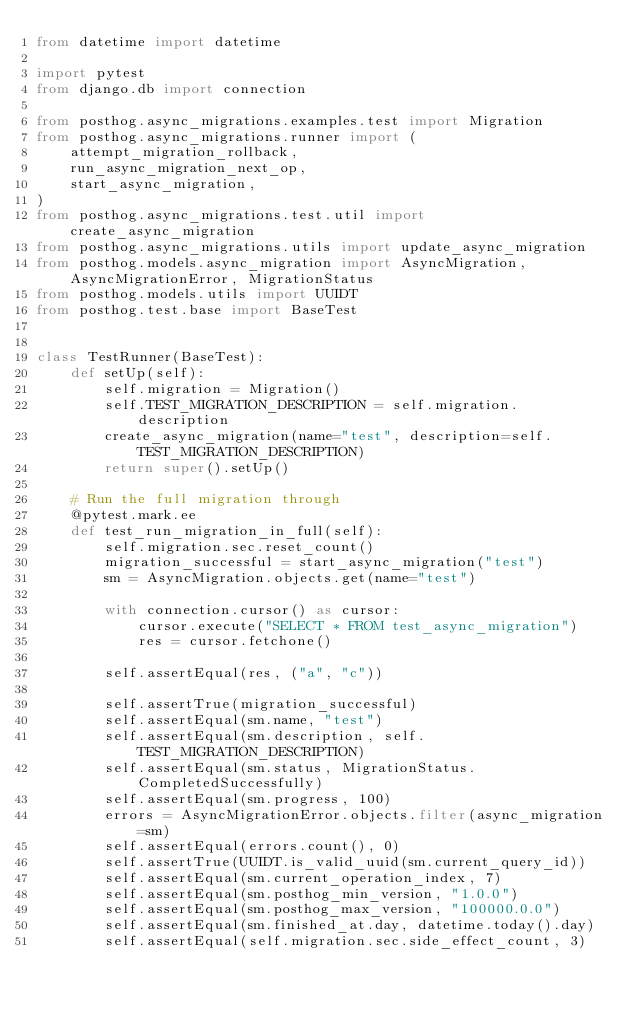<code> <loc_0><loc_0><loc_500><loc_500><_Python_>from datetime import datetime

import pytest
from django.db import connection

from posthog.async_migrations.examples.test import Migration
from posthog.async_migrations.runner import (
    attempt_migration_rollback,
    run_async_migration_next_op,
    start_async_migration,
)
from posthog.async_migrations.test.util import create_async_migration
from posthog.async_migrations.utils import update_async_migration
from posthog.models.async_migration import AsyncMigration, AsyncMigrationError, MigrationStatus
from posthog.models.utils import UUIDT
from posthog.test.base import BaseTest


class TestRunner(BaseTest):
    def setUp(self):
        self.migration = Migration()
        self.TEST_MIGRATION_DESCRIPTION = self.migration.description
        create_async_migration(name="test", description=self.TEST_MIGRATION_DESCRIPTION)
        return super().setUp()

    # Run the full migration through
    @pytest.mark.ee
    def test_run_migration_in_full(self):
        self.migration.sec.reset_count()
        migration_successful = start_async_migration("test")
        sm = AsyncMigration.objects.get(name="test")

        with connection.cursor() as cursor:
            cursor.execute("SELECT * FROM test_async_migration")
            res = cursor.fetchone()

        self.assertEqual(res, ("a", "c"))

        self.assertTrue(migration_successful)
        self.assertEqual(sm.name, "test")
        self.assertEqual(sm.description, self.TEST_MIGRATION_DESCRIPTION)
        self.assertEqual(sm.status, MigrationStatus.CompletedSuccessfully)
        self.assertEqual(sm.progress, 100)
        errors = AsyncMigrationError.objects.filter(async_migration=sm)
        self.assertEqual(errors.count(), 0)
        self.assertTrue(UUIDT.is_valid_uuid(sm.current_query_id))
        self.assertEqual(sm.current_operation_index, 7)
        self.assertEqual(sm.posthog_min_version, "1.0.0")
        self.assertEqual(sm.posthog_max_version, "100000.0.0")
        self.assertEqual(sm.finished_at.day, datetime.today().day)
        self.assertEqual(self.migration.sec.side_effect_count, 3)</code> 